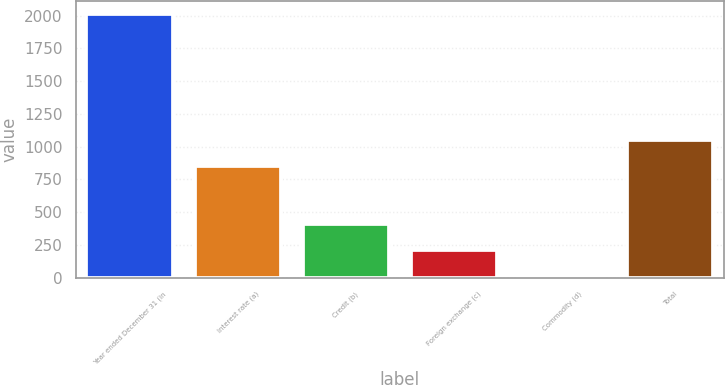<chart> <loc_0><loc_0><loc_500><loc_500><bar_chart><fcel>Year ended December 31 (in<fcel>Interest rate (a)<fcel>Credit (b)<fcel>Foreign exchange (c)<fcel>Commodity (d)<fcel>Total<nl><fcel>2015<fcel>853<fcel>412.6<fcel>212.3<fcel>12<fcel>1053.3<nl></chart> 